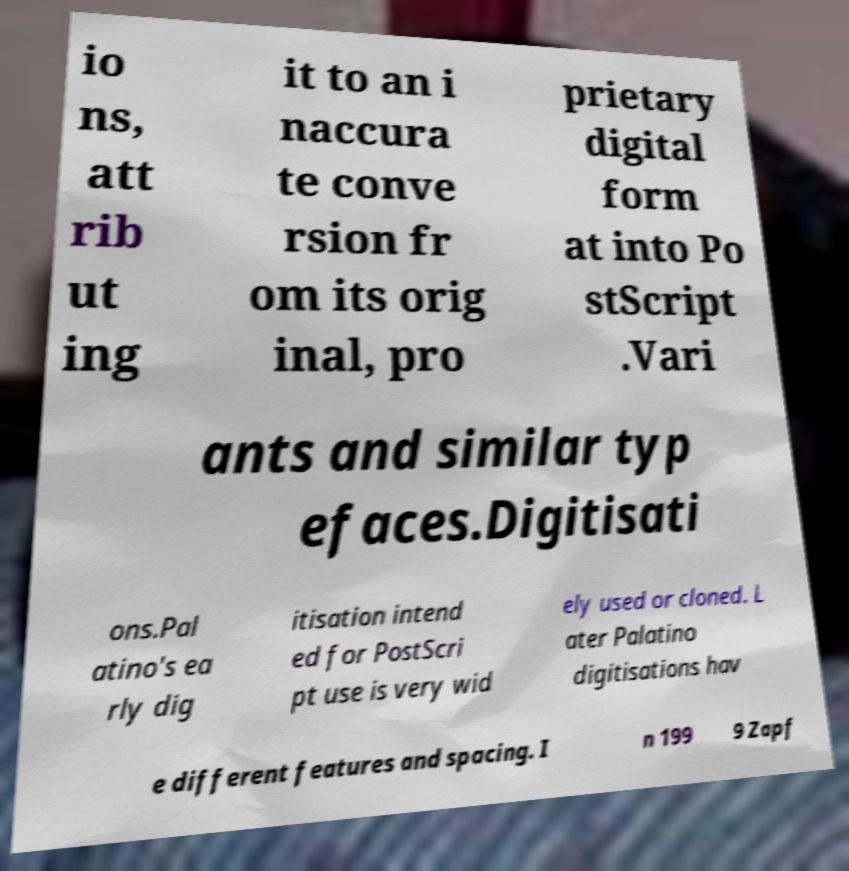For documentation purposes, I need the text within this image transcribed. Could you provide that? io ns, att rib ut ing it to an i naccura te conve rsion fr om its orig inal, pro prietary digital form at into Po stScript .Vari ants and similar typ efaces.Digitisati ons.Pal atino's ea rly dig itisation intend ed for PostScri pt use is very wid ely used or cloned. L ater Palatino digitisations hav e different features and spacing. I n 199 9 Zapf 